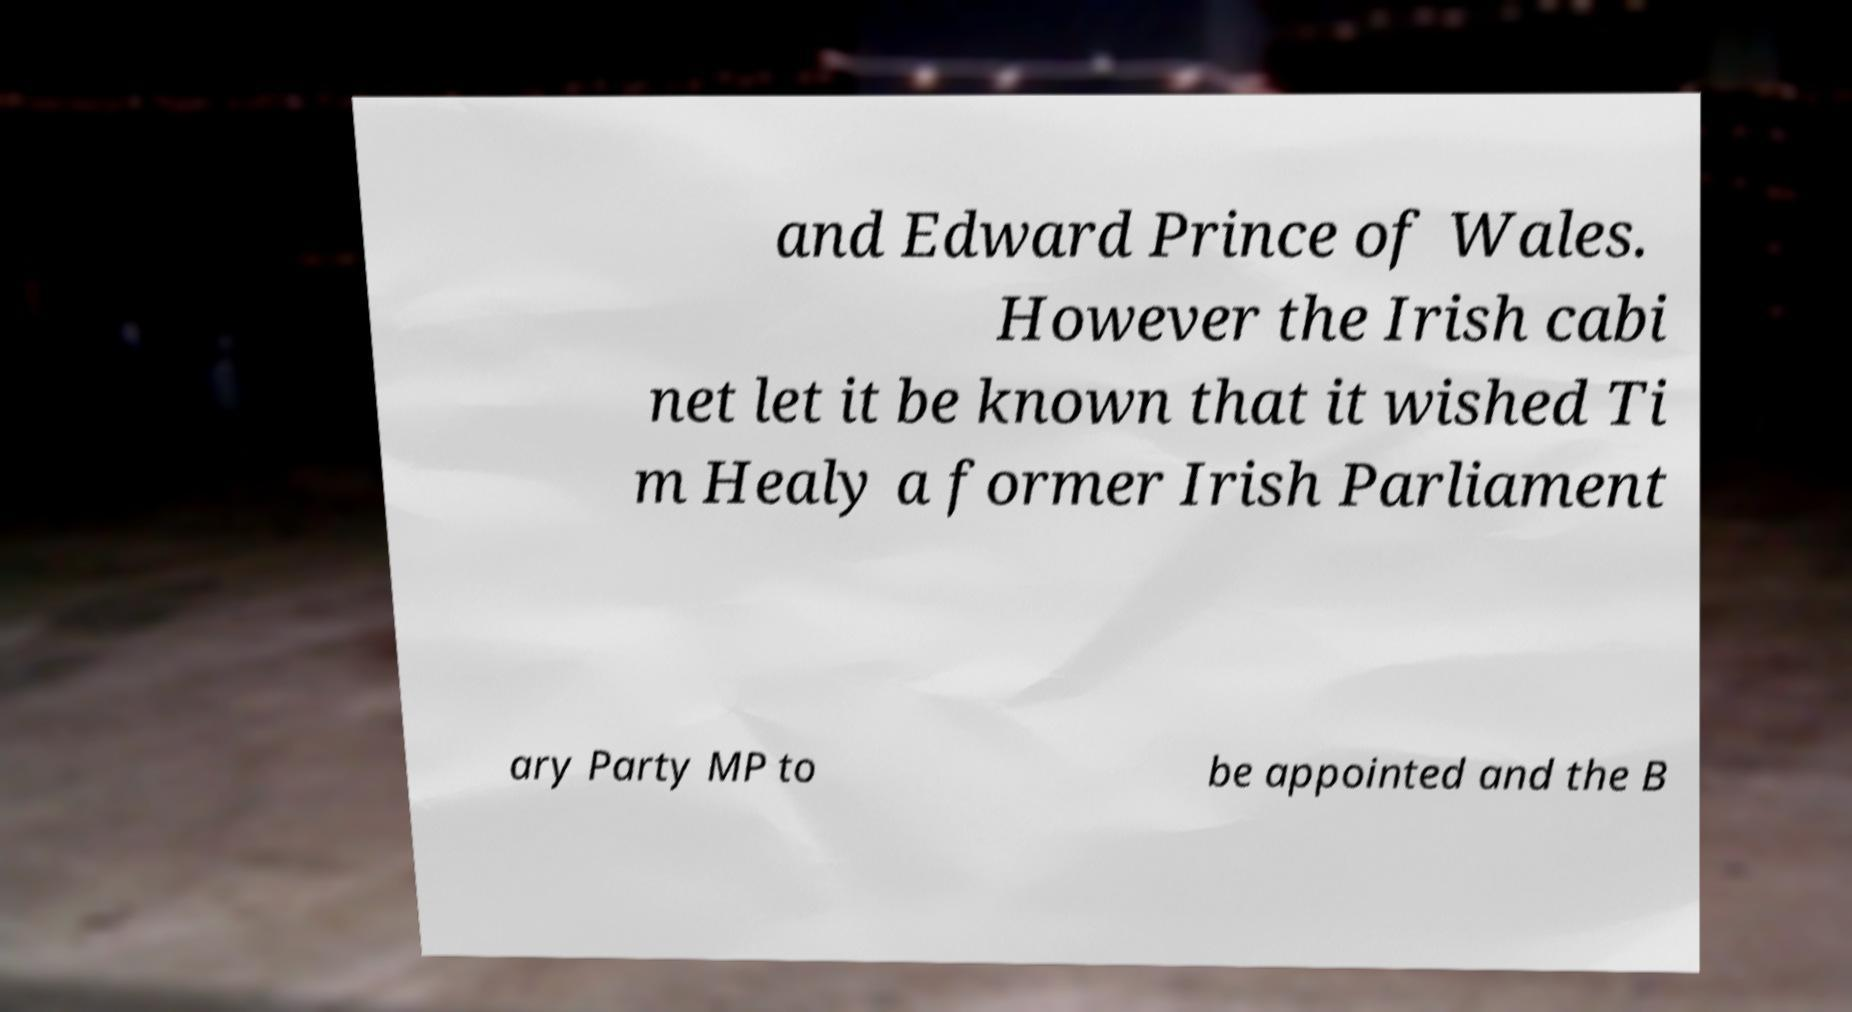Can you read and provide the text displayed in the image?This photo seems to have some interesting text. Can you extract and type it out for me? and Edward Prince of Wales. However the Irish cabi net let it be known that it wished Ti m Healy a former Irish Parliament ary Party MP to be appointed and the B 